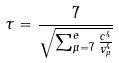Convert formula to latex. <formula><loc_0><loc_0><loc_500><loc_500>\tau = \frac { 7 } { \sqrt { \sum _ { \mu = 7 } ^ { e } \frac { c ^ { 4 } } { v _ { \mu } ^ { 4 } } } }</formula> 